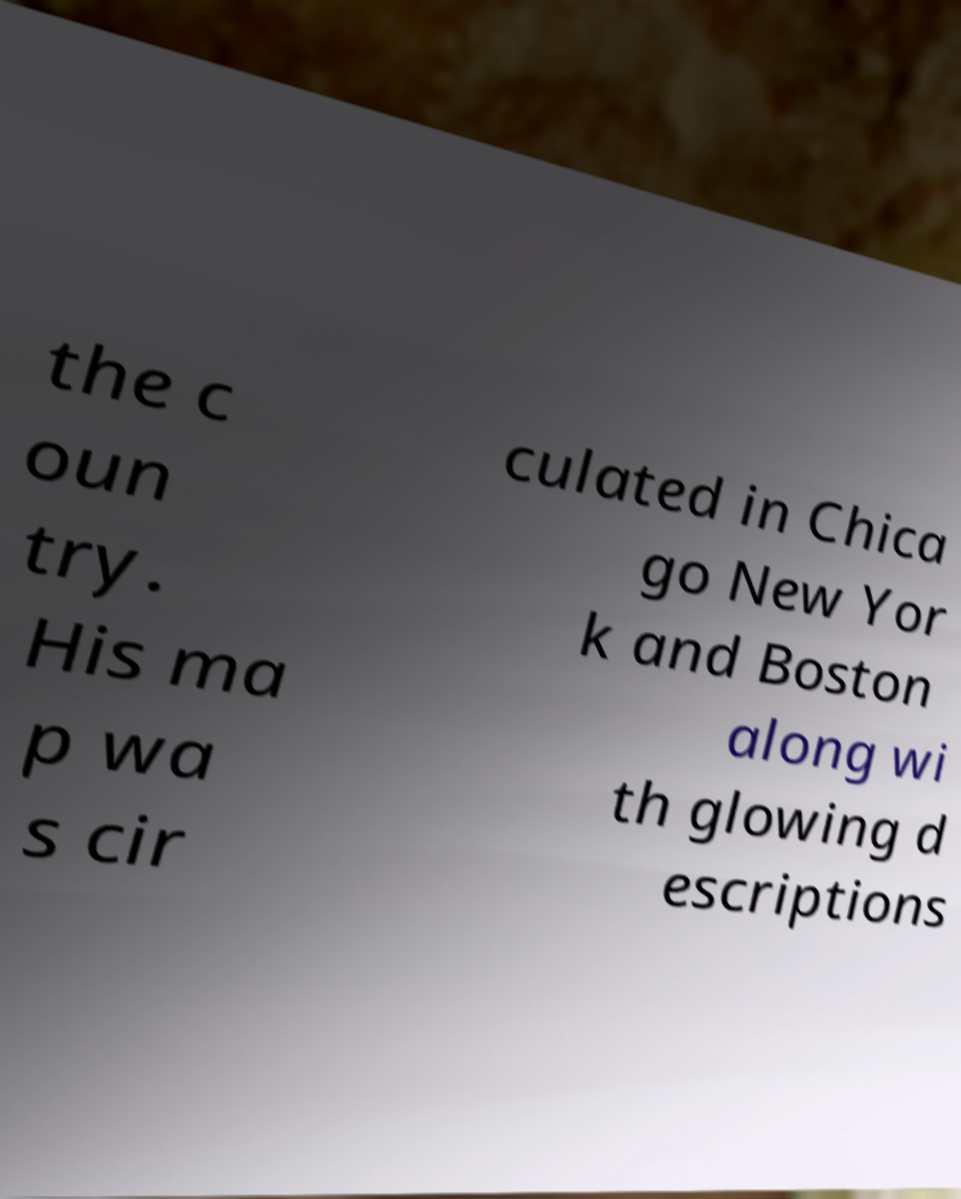Could you assist in decoding the text presented in this image and type it out clearly? the c oun try. His ma p wa s cir culated in Chica go New Yor k and Boston along wi th glowing d escriptions 